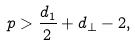Convert formula to latex. <formula><loc_0><loc_0><loc_500><loc_500>p > \frac { d _ { 1 } } { 2 } + d _ { \perp } - 2 ,</formula> 